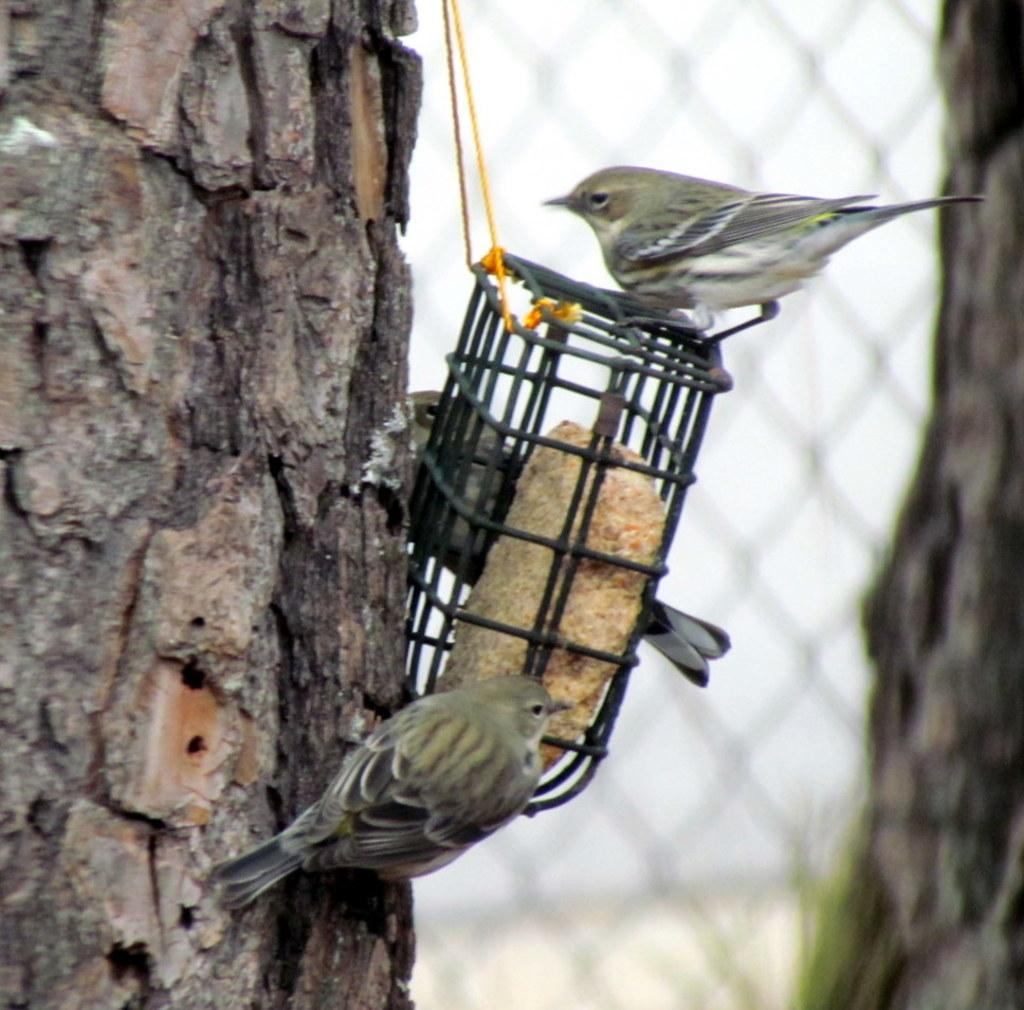What type of natural objects can be seen in the image? There are tree trunks in the image. What animals are present in the image? There are birds in the image. Can you describe the object hanging in the image? The object is hanging and tied with ropes. How would you describe the background of the image? The background of the image is blurred. What type of scarf is the bird wearing in the image? There is no scarf present in the image, and the birds are not wearing any clothing. How many apples are visible in the image? There are no apples present in the image. 